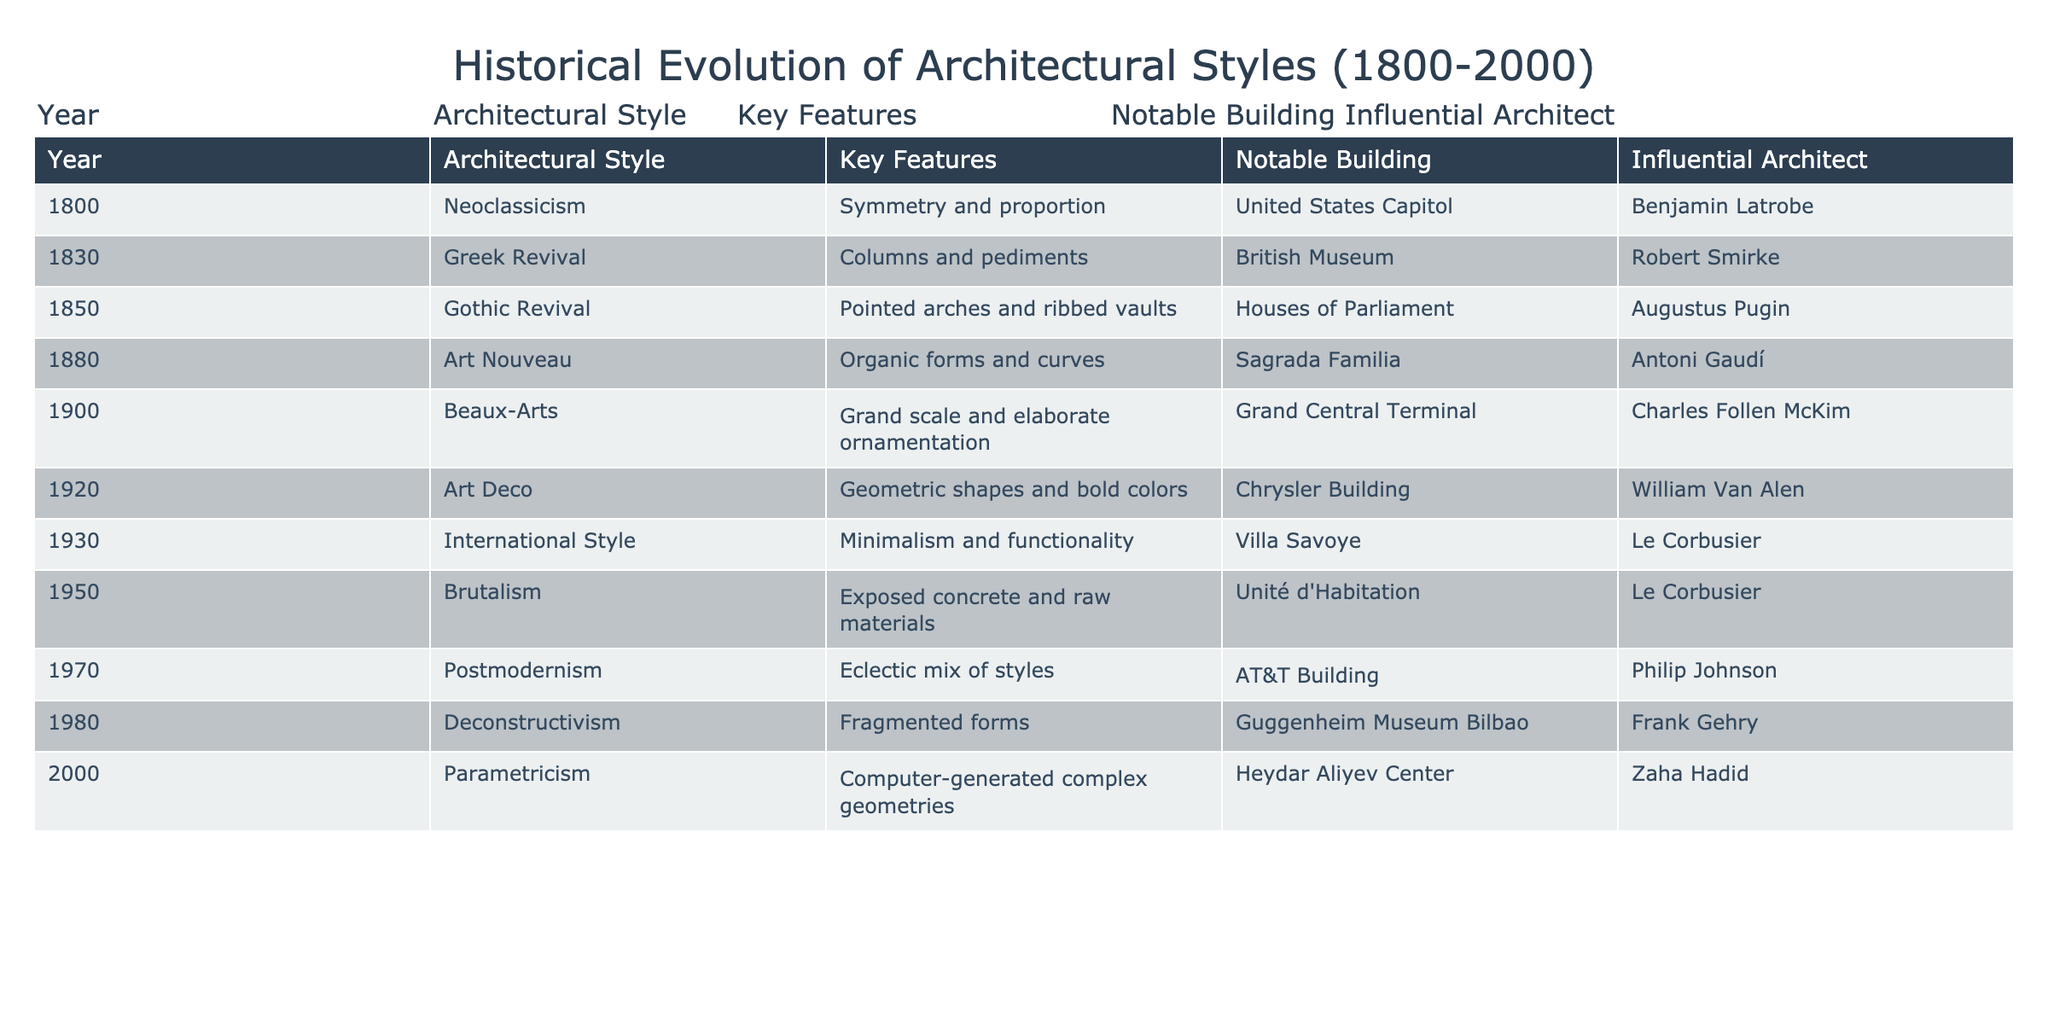What architectural style was prominent in 1850? The table lists the architectural styles along with their corresponding years. By locating the year 1850 in the table, we can see that the architectural style was Gothic Revival.
Answer: Gothic Revival Which notable building is associated with Art Nouveau? Referring to the table, we find the row for Art Nouveau, which indicates that the Sagrada Familia is the notable building linked to this architectural style.
Answer: Sagrada Familia How many architectural styles were noted between 1900 and 1950? We need to count the number of styles listed in the years 1900, 1920, 1930, and 1950. The styles are Beaux-Arts, Art Deco, International Style, and Brutalism, totaling four distinct styles.
Answer: 4 Was Brutalism characterized by exposed concrete? According to the table, the key features of Brutalism are indeed listed as exposed concrete and raw materials, confirming that the statement is true.
Answer: Yes Which architectural style saw the use of geometric shapes and bold colors, and who was the influential architect? The table states that Art Deco is characterized by geometric shapes and bold colors. It further describes William Van Alen as the influential architect for this style.
Answer: Art Deco, William Van Alen What is the difference in the number of years between the first adoption of Neoclassicism and the introduction of Parametricism? Neoclassicism was introduced in 1800 and Parametricism in 2000. The difference in years is 2000 - 1800 = 200 years.
Answer: 200 years Identify two architectural styles that featured a notable building related to a European structure. Looking at the table, we can observe that the Gothic Revival had the Houses of Parliament and the Beaux-Arts style had Grand Central Terminal. Both buildings represent significant European architecture.
Answer: Gothic Revival, Beaux-Arts Is Postmodernism characterized by a single, unified style? The table shows that Postmodernism features an eclectic mix of styles, suggesting it does not adhere to a singular aesthetic. Therefore, the statement is false.
Answer: No How many styles have been influenced by the architect Le Corbusier? By reviewing the table, we can identify that Le Corbusier influenced two styles: the International Style and Brutalism, noted in their respective rows.
Answer: 2 